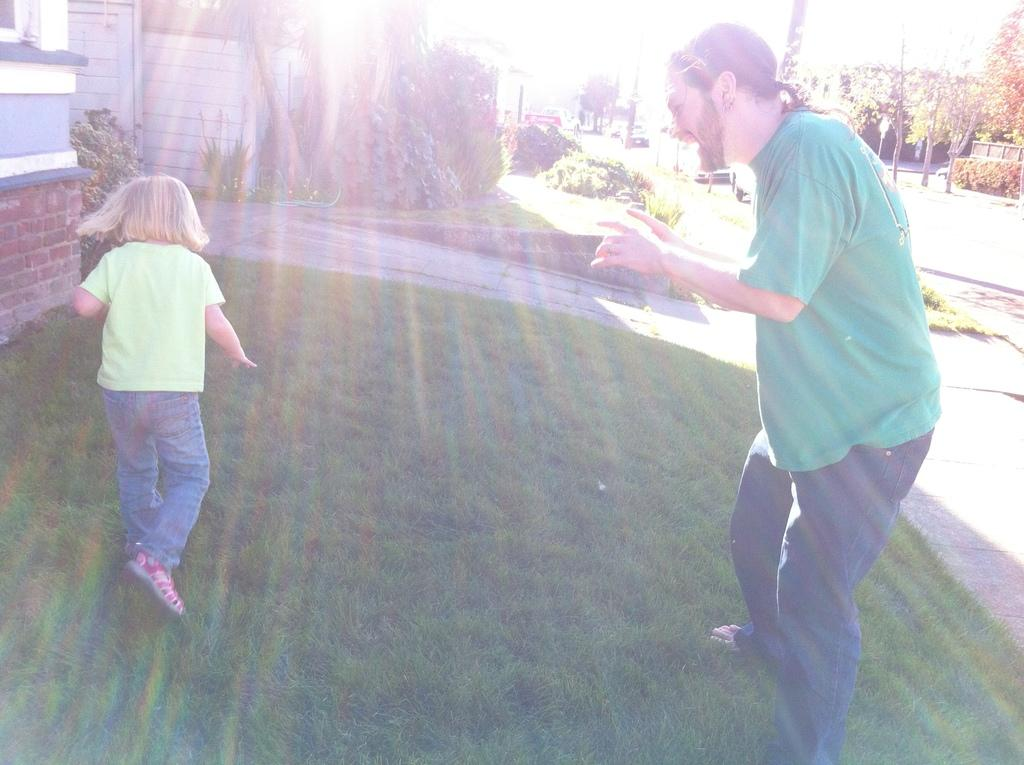Who are the people in the foreground of the image? There is a man and a small girl in the foreground of the image. What is the setting of the image? They are on a grassland. What can be seen in the background of the image? There are houses, trees, poles, and the sky visible in the background of the image. What decision did the man make regarding the paper in the image? There is no paper present in the image, and therefore no decision regarding paper can be observed. 